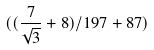Convert formula to latex. <formula><loc_0><loc_0><loc_500><loc_500>( ( \frac { 7 } { \sqrt { 3 } } + 8 ) / 1 9 7 + 8 7 )</formula> 